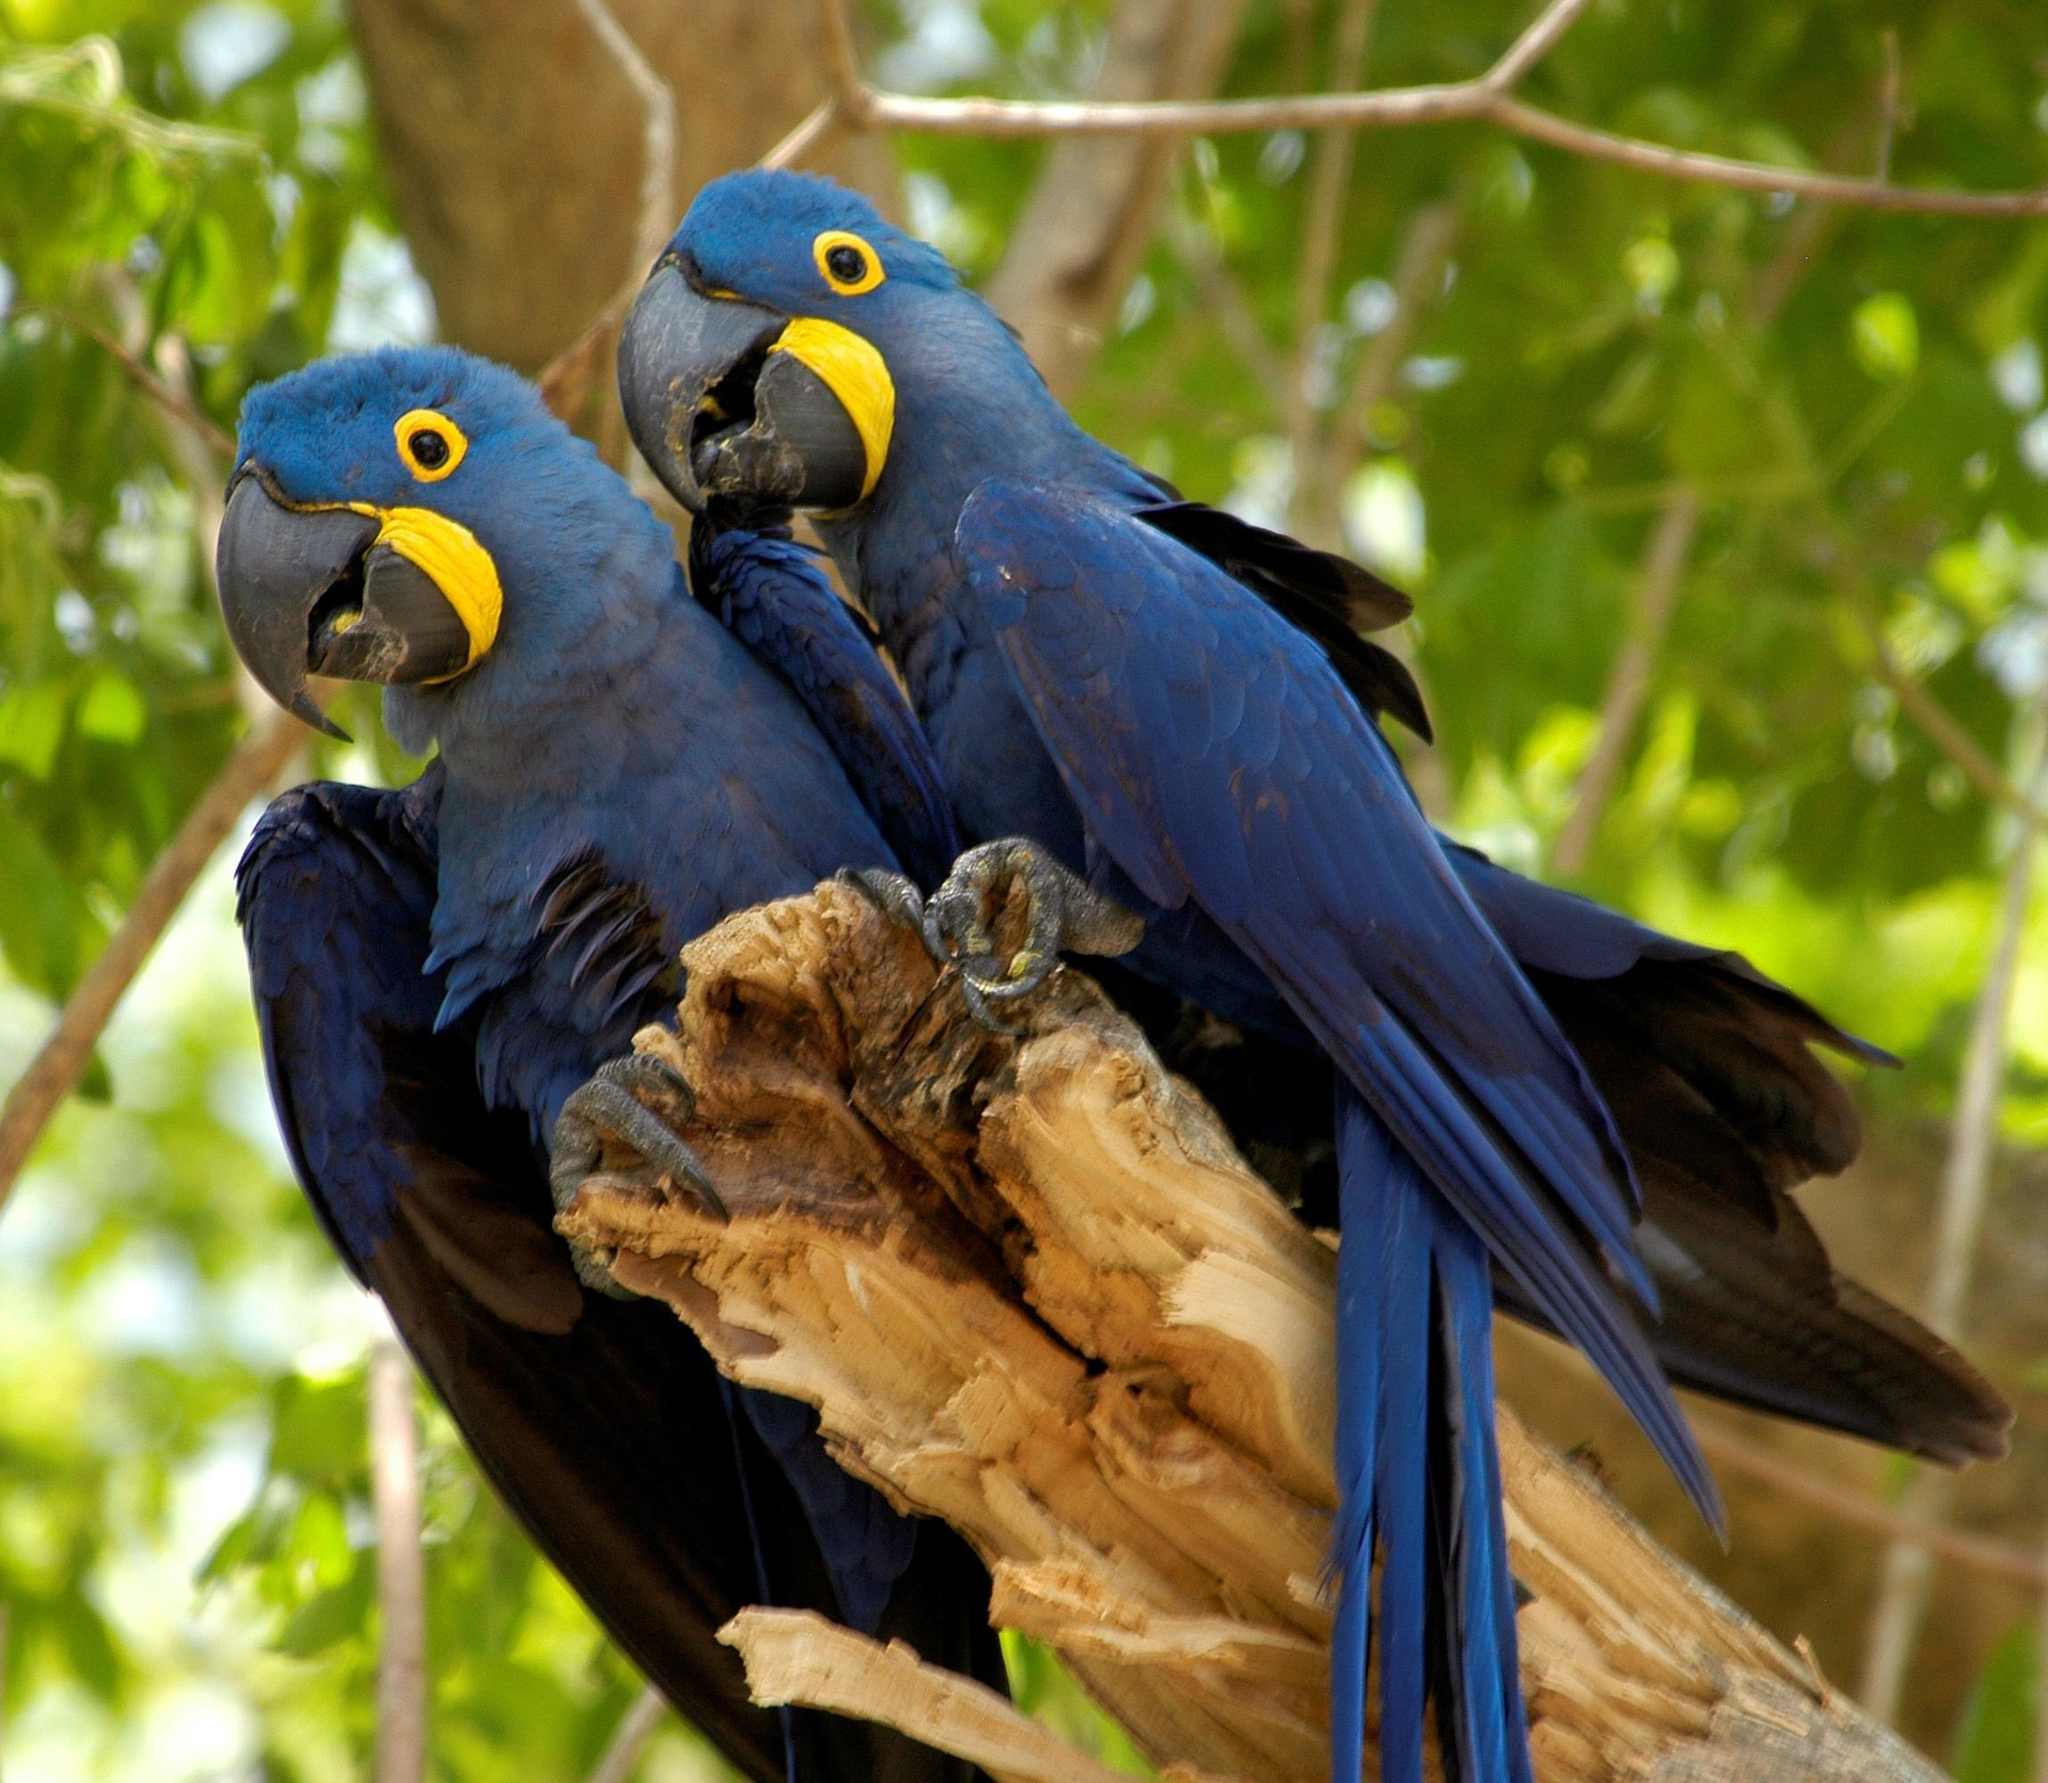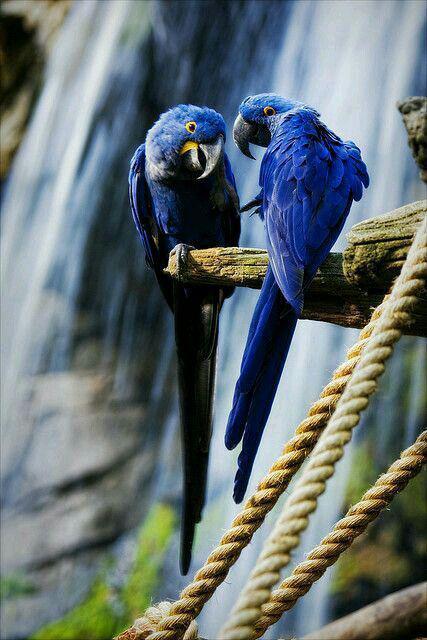The first image is the image on the left, the second image is the image on the right. Examine the images to the left and right. Is the description "An image shows exactly one parrot, which is blue." accurate? Answer yes or no. No. The first image is the image on the left, the second image is the image on the right. For the images displayed, is the sentence "In one image, a single blue parrot is sitting on a perch." factually correct? Answer yes or no. No. 